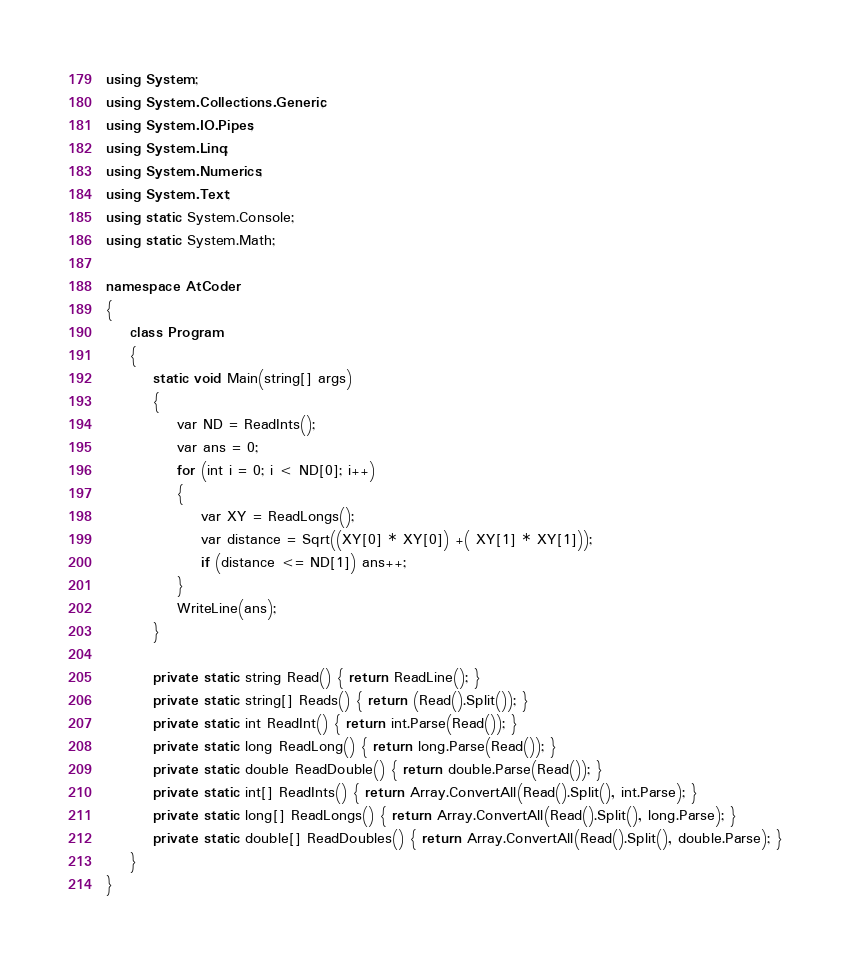<code> <loc_0><loc_0><loc_500><loc_500><_C#_>using System;
using System.Collections.Generic;
using System.IO.Pipes;
using System.Linq;
using System.Numerics;
using System.Text;
using static System.Console;
using static System.Math;

namespace AtCoder
{
    class Program
    {
        static void Main(string[] args)
        {
            var ND = ReadInts();
            var ans = 0;
            for (int i = 0; i < ND[0]; i++)
            {
                var XY = ReadLongs();
                var distance = Sqrt((XY[0] * XY[0]) +( XY[1] * XY[1]));
                if (distance <= ND[1]) ans++;
            }
            WriteLine(ans);
        }

        private static string Read() { return ReadLine(); }
        private static string[] Reads() { return (Read().Split()); }
        private static int ReadInt() { return int.Parse(Read()); }
        private static long ReadLong() { return long.Parse(Read()); }
        private static double ReadDouble() { return double.Parse(Read()); }
        private static int[] ReadInts() { return Array.ConvertAll(Read().Split(), int.Parse); }
        private static long[] ReadLongs() { return Array.ConvertAll(Read().Split(), long.Parse); }
        private static double[] ReadDoubles() { return Array.ConvertAll(Read().Split(), double.Parse); }
    }
}
</code> 